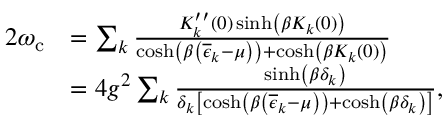Convert formula to latex. <formula><loc_0><loc_0><loc_500><loc_500>\begin{array} { r l } { 2 \omega _ { c } } & { = \sum _ { k } \frac { K _ { k } ^ { \prime \prime } ( 0 ) \sinh \left ( \beta K _ { k } ( 0 ) \right ) } { \cosh \left ( \beta \left ( \overline { \epsilon } _ { k } - \mu \right ) \right ) + \cosh \left ( \beta K _ { k } ( 0 ) \right ) } } \\ & { = 4 g ^ { 2 } \sum _ { k } \frac { \sinh \left ( \beta \delta _ { k } \right ) } { \delta _ { k } \left [ \cosh \left ( \beta \left ( \overline { \epsilon } _ { k } - \mu \right ) \right ) + \cosh \left ( \beta \delta _ { k } \right ) \right ] } , } \end{array}</formula> 